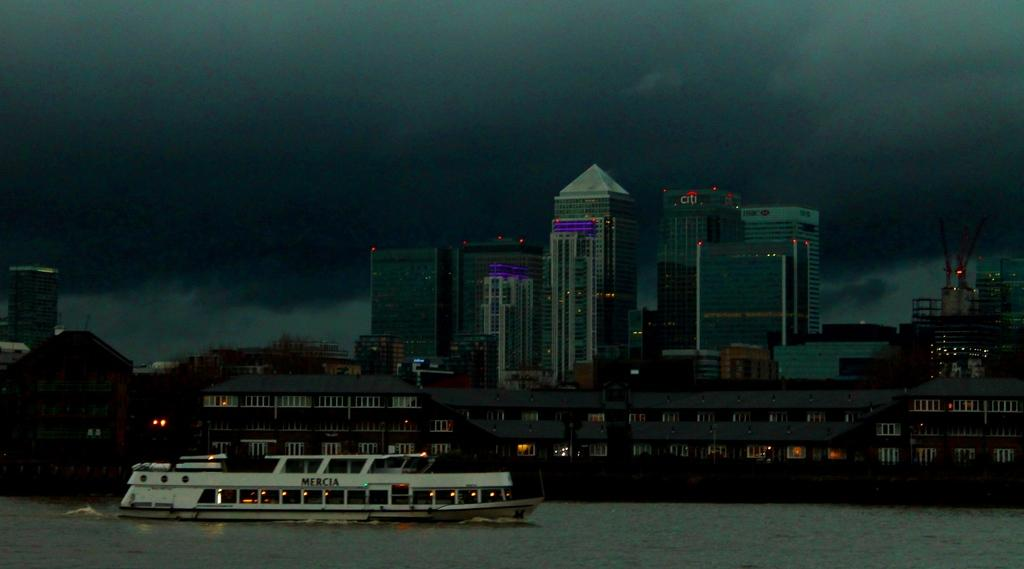<image>
Render a clear and concise summary of the photo. A boat called Mercia is sailing on a dark overcast day. 